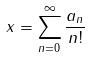<formula> <loc_0><loc_0><loc_500><loc_500>x = \sum _ { n = 0 } ^ { \infty } \frac { a _ { n } } { n ! }</formula> 